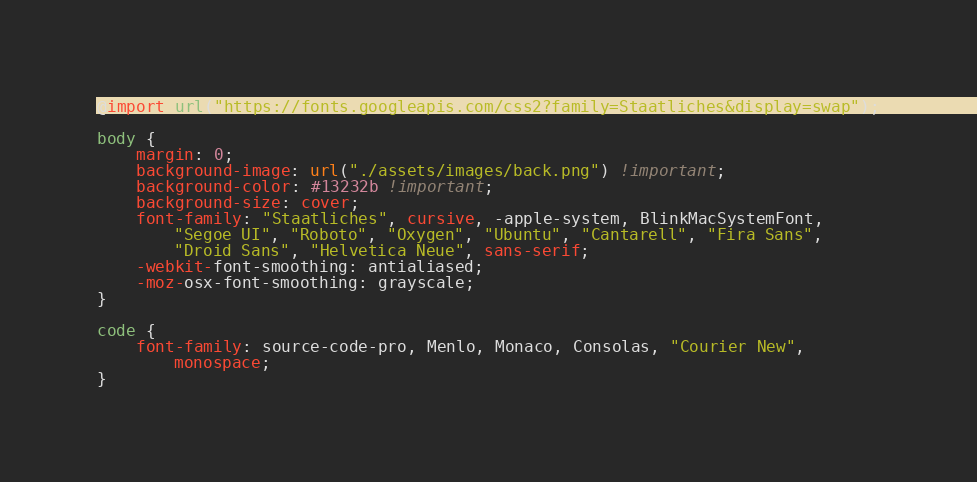Convert code to text. <code><loc_0><loc_0><loc_500><loc_500><_CSS_>@import url("https://fonts.googleapis.com/css2?family=Staatliches&display=swap");

body {
	margin: 0;
	background-image: url("./assets/images/back.png") !important;
	background-color: #13232b !important;
	background-size: cover;
	font-family: "Staatliches", cursive, -apple-system, BlinkMacSystemFont,
		"Segoe UI", "Roboto", "Oxygen", "Ubuntu", "Cantarell", "Fira Sans",
		"Droid Sans", "Helvetica Neue", sans-serif;
	-webkit-font-smoothing: antialiased;
	-moz-osx-font-smoothing: grayscale;
}

code {
	font-family: source-code-pro, Menlo, Monaco, Consolas, "Courier New",
		monospace;
}
</code> 